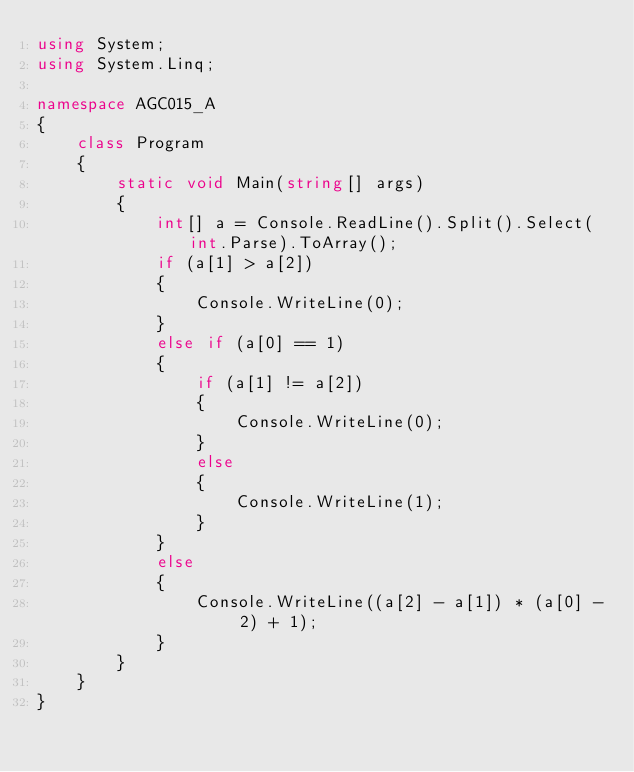<code> <loc_0><loc_0><loc_500><loc_500><_C#_>using System;
using System.Linq;

namespace AGC015_A
{
    class Program
    {
        static void Main(string[] args)
        {
            int[] a = Console.ReadLine().Split().Select(int.Parse).ToArray();
            if (a[1] > a[2])
            {
                Console.WriteLine(0);
            }
            else if (a[0] == 1)
            {
                if (a[1] != a[2])
                {
                    Console.WriteLine(0);
                }
                else
                {
                    Console.WriteLine(1);
                }
            }
            else
            {
                Console.WriteLine((a[2] - a[1]) * (a[0] - 2) + 1);
            }
        }
    }
}
</code> 